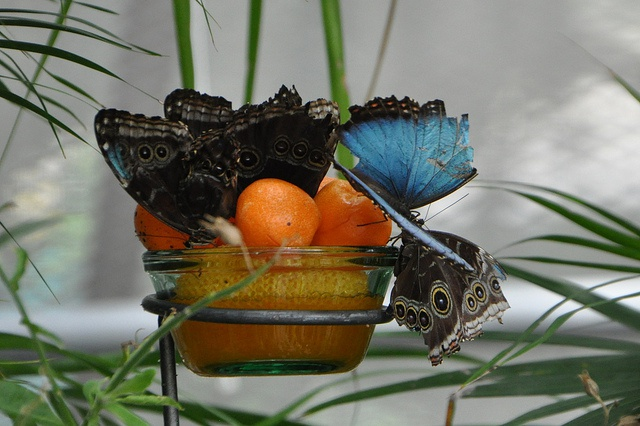Describe the objects in this image and their specific colors. I can see bowl in gray, maroon, black, and olive tones, orange in gray, red, maroon, and orange tones, orange in gray, maroon, red, and tan tones, and orange in gray, maroon, and black tones in this image. 